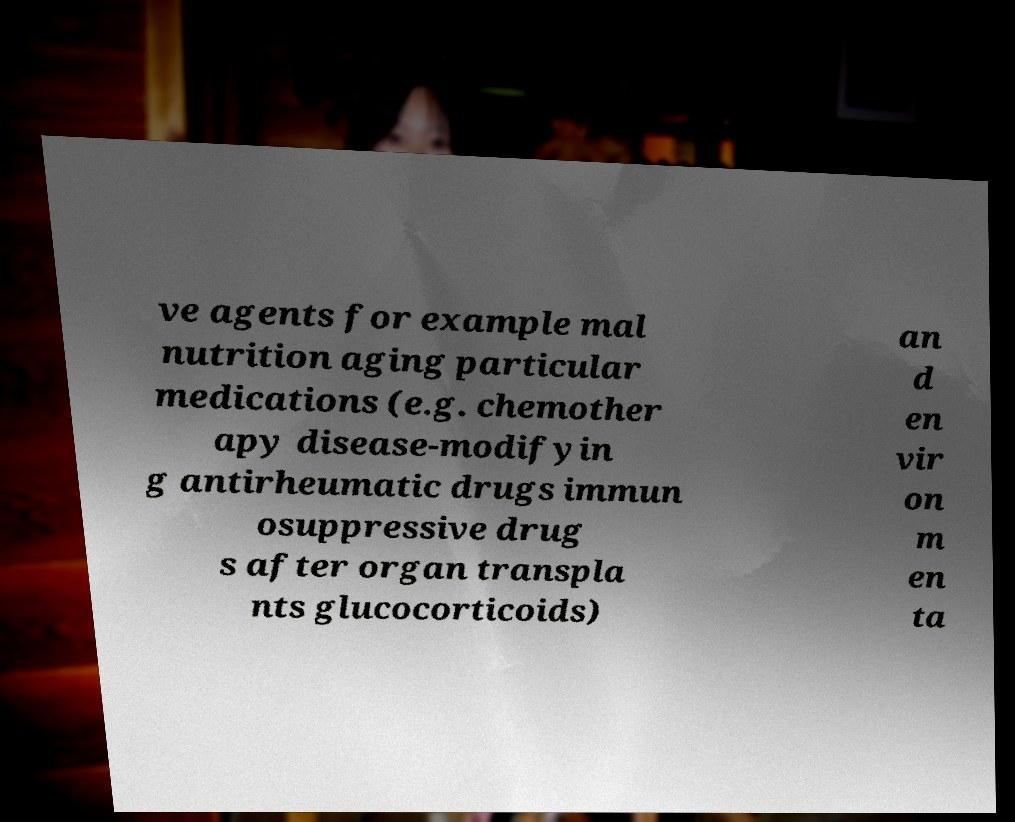Please identify and transcribe the text found in this image. ve agents for example mal nutrition aging particular medications (e.g. chemother apy disease-modifyin g antirheumatic drugs immun osuppressive drug s after organ transpla nts glucocorticoids) an d en vir on m en ta 